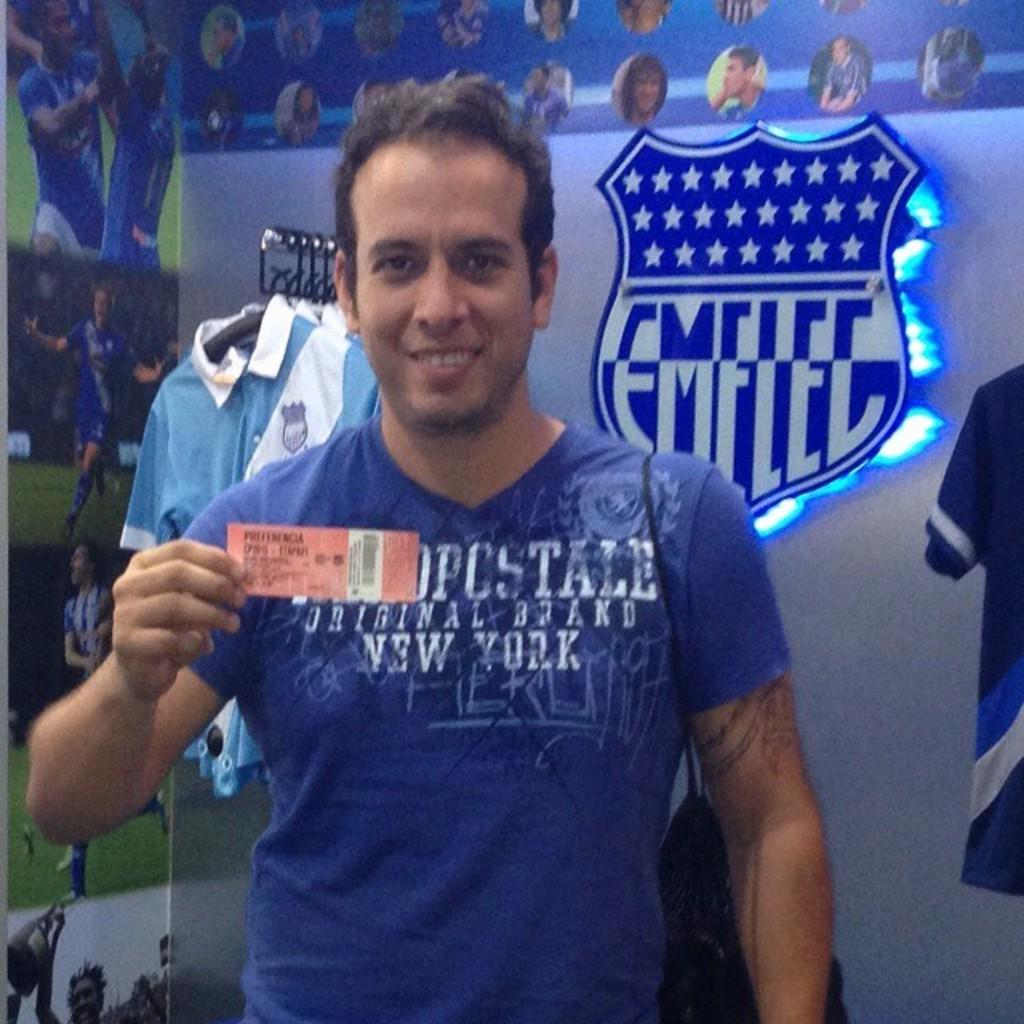<image>
Provide a brief description of the given image. A man wearing a blue Original Brand New York t-shirt is holding up a ticket behind a banner 